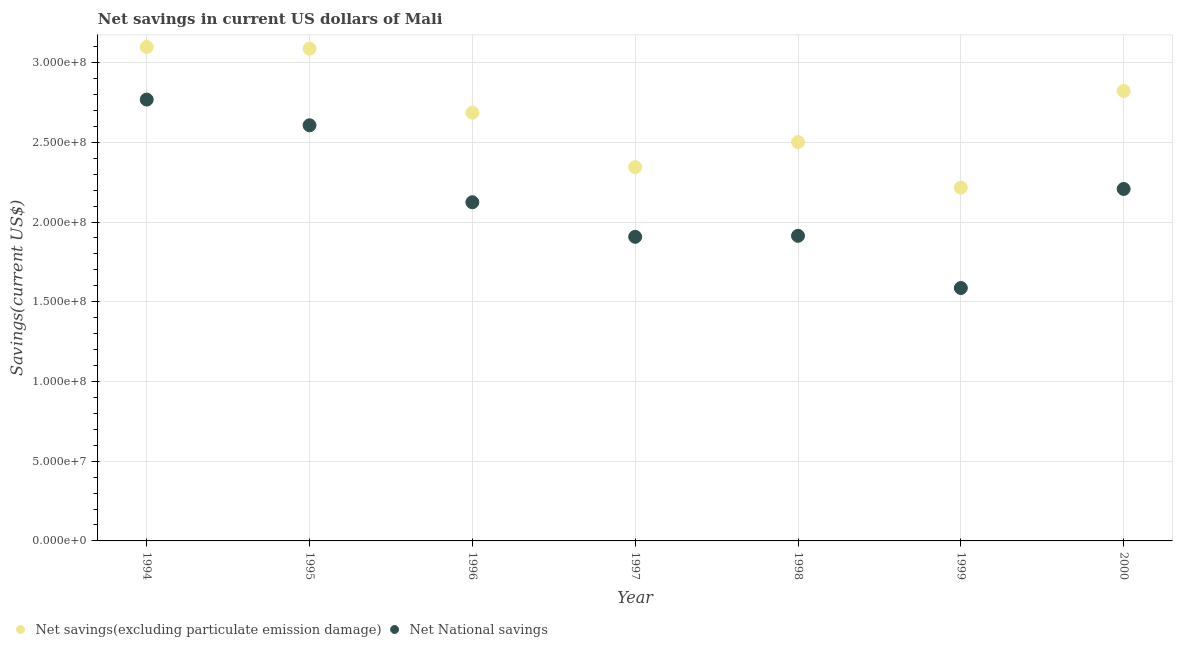What is the net savings(excluding particulate emission damage) in 1995?
Ensure brevity in your answer.  3.09e+08. Across all years, what is the maximum net national savings?
Your answer should be compact. 2.77e+08. Across all years, what is the minimum net national savings?
Your answer should be very brief. 1.59e+08. What is the total net savings(excluding particulate emission damage) in the graph?
Offer a very short reply. 1.88e+09. What is the difference between the net savings(excluding particulate emission damage) in 1999 and that in 2000?
Provide a short and direct response. -6.06e+07. What is the difference between the net national savings in 1999 and the net savings(excluding particulate emission damage) in 1996?
Give a very brief answer. -1.10e+08. What is the average net savings(excluding particulate emission damage) per year?
Your response must be concise. 2.68e+08. In the year 1998, what is the difference between the net savings(excluding particulate emission damage) and net national savings?
Provide a short and direct response. 5.88e+07. In how many years, is the net national savings greater than 140000000 US$?
Offer a terse response. 7. What is the ratio of the net savings(excluding particulate emission damage) in 1994 to that in 1998?
Your answer should be very brief. 1.24. What is the difference between the highest and the second highest net savings(excluding particulate emission damage)?
Provide a short and direct response. 1.12e+06. What is the difference between the highest and the lowest net national savings?
Make the answer very short. 1.18e+08. How many dotlines are there?
Ensure brevity in your answer.  2. How many years are there in the graph?
Your answer should be very brief. 7. Does the graph contain any zero values?
Provide a short and direct response. No. Where does the legend appear in the graph?
Make the answer very short. Bottom left. How are the legend labels stacked?
Offer a terse response. Horizontal. What is the title of the graph?
Your response must be concise. Net savings in current US dollars of Mali. Does "Register a business" appear as one of the legend labels in the graph?
Offer a very short reply. No. What is the label or title of the X-axis?
Your answer should be very brief. Year. What is the label or title of the Y-axis?
Make the answer very short. Savings(current US$). What is the Savings(current US$) in Net savings(excluding particulate emission damage) in 1994?
Offer a terse response. 3.10e+08. What is the Savings(current US$) of Net National savings in 1994?
Offer a terse response. 2.77e+08. What is the Savings(current US$) of Net savings(excluding particulate emission damage) in 1995?
Provide a succinct answer. 3.09e+08. What is the Savings(current US$) in Net National savings in 1995?
Your answer should be compact. 2.61e+08. What is the Savings(current US$) of Net savings(excluding particulate emission damage) in 1996?
Provide a succinct answer. 2.69e+08. What is the Savings(current US$) of Net National savings in 1996?
Your answer should be very brief. 2.12e+08. What is the Savings(current US$) in Net savings(excluding particulate emission damage) in 1997?
Your answer should be compact. 2.34e+08. What is the Savings(current US$) of Net National savings in 1997?
Offer a very short reply. 1.91e+08. What is the Savings(current US$) of Net savings(excluding particulate emission damage) in 1998?
Ensure brevity in your answer.  2.50e+08. What is the Savings(current US$) of Net National savings in 1998?
Your answer should be compact. 1.91e+08. What is the Savings(current US$) in Net savings(excluding particulate emission damage) in 1999?
Ensure brevity in your answer.  2.22e+08. What is the Savings(current US$) in Net National savings in 1999?
Your response must be concise. 1.59e+08. What is the Savings(current US$) in Net savings(excluding particulate emission damage) in 2000?
Offer a very short reply. 2.82e+08. What is the Savings(current US$) in Net National savings in 2000?
Offer a very short reply. 2.21e+08. Across all years, what is the maximum Savings(current US$) in Net savings(excluding particulate emission damage)?
Offer a terse response. 3.10e+08. Across all years, what is the maximum Savings(current US$) of Net National savings?
Offer a very short reply. 2.77e+08. Across all years, what is the minimum Savings(current US$) of Net savings(excluding particulate emission damage)?
Your response must be concise. 2.22e+08. Across all years, what is the minimum Savings(current US$) of Net National savings?
Your answer should be very brief. 1.59e+08. What is the total Savings(current US$) in Net savings(excluding particulate emission damage) in the graph?
Your answer should be compact. 1.88e+09. What is the total Savings(current US$) in Net National savings in the graph?
Your answer should be compact. 1.51e+09. What is the difference between the Savings(current US$) of Net savings(excluding particulate emission damage) in 1994 and that in 1995?
Make the answer very short. 1.12e+06. What is the difference between the Savings(current US$) in Net National savings in 1994 and that in 1995?
Ensure brevity in your answer.  1.61e+07. What is the difference between the Savings(current US$) of Net savings(excluding particulate emission damage) in 1994 and that in 1996?
Offer a terse response. 4.13e+07. What is the difference between the Savings(current US$) of Net National savings in 1994 and that in 1996?
Your answer should be very brief. 6.44e+07. What is the difference between the Savings(current US$) in Net savings(excluding particulate emission damage) in 1994 and that in 1997?
Give a very brief answer. 7.54e+07. What is the difference between the Savings(current US$) in Net National savings in 1994 and that in 1997?
Keep it short and to the point. 8.61e+07. What is the difference between the Savings(current US$) of Net savings(excluding particulate emission damage) in 1994 and that in 1998?
Make the answer very short. 5.97e+07. What is the difference between the Savings(current US$) in Net National savings in 1994 and that in 1998?
Your response must be concise. 8.54e+07. What is the difference between the Savings(current US$) in Net savings(excluding particulate emission damage) in 1994 and that in 1999?
Provide a short and direct response. 8.82e+07. What is the difference between the Savings(current US$) in Net National savings in 1994 and that in 1999?
Offer a terse response. 1.18e+08. What is the difference between the Savings(current US$) in Net savings(excluding particulate emission damage) in 1994 and that in 2000?
Keep it short and to the point. 2.76e+07. What is the difference between the Savings(current US$) of Net National savings in 1994 and that in 2000?
Provide a short and direct response. 5.61e+07. What is the difference between the Savings(current US$) of Net savings(excluding particulate emission damage) in 1995 and that in 1996?
Provide a succinct answer. 4.02e+07. What is the difference between the Savings(current US$) in Net National savings in 1995 and that in 1996?
Ensure brevity in your answer.  4.83e+07. What is the difference between the Savings(current US$) of Net savings(excluding particulate emission damage) in 1995 and that in 1997?
Your answer should be compact. 7.43e+07. What is the difference between the Savings(current US$) in Net National savings in 1995 and that in 1997?
Provide a succinct answer. 6.99e+07. What is the difference between the Savings(current US$) of Net savings(excluding particulate emission damage) in 1995 and that in 1998?
Make the answer very short. 5.85e+07. What is the difference between the Savings(current US$) in Net National savings in 1995 and that in 1998?
Offer a very short reply. 6.93e+07. What is the difference between the Savings(current US$) in Net savings(excluding particulate emission damage) in 1995 and that in 1999?
Your answer should be compact. 8.71e+07. What is the difference between the Savings(current US$) of Net National savings in 1995 and that in 1999?
Offer a very short reply. 1.02e+08. What is the difference between the Savings(current US$) in Net savings(excluding particulate emission damage) in 1995 and that in 2000?
Offer a terse response. 2.65e+07. What is the difference between the Savings(current US$) of Net National savings in 1995 and that in 2000?
Your answer should be compact. 3.99e+07. What is the difference between the Savings(current US$) of Net savings(excluding particulate emission damage) in 1996 and that in 1997?
Provide a short and direct response. 3.41e+07. What is the difference between the Savings(current US$) of Net National savings in 1996 and that in 1997?
Offer a terse response. 2.17e+07. What is the difference between the Savings(current US$) in Net savings(excluding particulate emission damage) in 1996 and that in 1998?
Keep it short and to the point. 1.84e+07. What is the difference between the Savings(current US$) of Net National savings in 1996 and that in 1998?
Your answer should be compact. 2.11e+07. What is the difference between the Savings(current US$) of Net savings(excluding particulate emission damage) in 1996 and that in 1999?
Provide a succinct answer. 4.70e+07. What is the difference between the Savings(current US$) in Net National savings in 1996 and that in 1999?
Ensure brevity in your answer.  5.38e+07. What is the difference between the Savings(current US$) in Net savings(excluding particulate emission damage) in 1996 and that in 2000?
Make the answer very short. -1.36e+07. What is the difference between the Savings(current US$) of Net National savings in 1996 and that in 2000?
Make the answer very short. -8.33e+06. What is the difference between the Savings(current US$) in Net savings(excluding particulate emission damage) in 1997 and that in 1998?
Offer a terse response. -1.57e+07. What is the difference between the Savings(current US$) of Net National savings in 1997 and that in 1998?
Your response must be concise. -6.31e+05. What is the difference between the Savings(current US$) of Net savings(excluding particulate emission damage) in 1997 and that in 1999?
Your response must be concise. 1.29e+07. What is the difference between the Savings(current US$) in Net National savings in 1997 and that in 1999?
Provide a short and direct response. 3.21e+07. What is the difference between the Savings(current US$) of Net savings(excluding particulate emission damage) in 1997 and that in 2000?
Make the answer very short. -4.77e+07. What is the difference between the Savings(current US$) in Net National savings in 1997 and that in 2000?
Keep it short and to the point. -3.00e+07. What is the difference between the Savings(current US$) of Net savings(excluding particulate emission damage) in 1998 and that in 1999?
Make the answer very short. 2.86e+07. What is the difference between the Savings(current US$) of Net National savings in 1998 and that in 1999?
Your answer should be very brief. 3.27e+07. What is the difference between the Savings(current US$) of Net savings(excluding particulate emission damage) in 1998 and that in 2000?
Make the answer very short. -3.20e+07. What is the difference between the Savings(current US$) of Net National savings in 1998 and that in 2000?
Offer a terse response. -2.94e+07. What is the difference between the Savings(current US$) in Net savings(excluding particulate emission damage) in 1999 and that in 2000?
Your answer should be very brief. -6.06e+07. What is the difference between the Savings(current US$) in Net National savings in 1999 and that in 2000?
Give a very brief answer. -6.21e+07. What is the difference between the Savings(current US$) of Net savings(excluding particulate emission damage) in 1994 and the Savings(current US$) of Net National savings in 1995?
Make the answer very short. 4.91e+07. What is the difference between the Savings(current US$) of Net savings(excluding particulate emission damage) in 1994 and the Savings(current US$) of Net National savings in 1996?
Make the answer very short. 9.74e+07. What is the difference between the Savings(current US$) of Net savings(excluding particulate emission damage) in 1994 and the Savings(current US$) of Net National savings in 1997?
Keep it short and to the point. 1.19e+08. What is the difference between the Savings(current US$) in Net savings(excluding particulate emission damage) in 1994 and the Savings(current US$) in Net National savings in 1998?
Ensure brevity in your answer.  1.18e+08. What is the difference between the Savings(current US$) in Net savings(excluding particulate emission damage) in 1994 and the Savings(current US$) in Net National savings in 1999?
Keep it short and to the point. 1.51e+08. What is the difference between the Savings(current US$) in Net savings(excluding particulate emission damage) in 1994 and the Savings(current US$) in Net National savings in 2000?
Give a very brief answer. 8.91e+07. What is the difference between the Savings(current US$) in Net savings(excluding particulate emission damage) in 1995 and the Savings(current US$) in Net National savings in 1996?
Ensure brevity in your answer.  9.63e+07. What is the difference between the Savings(current US$) in Net savings(excluding particulate emission damage) in 1995 and the Savings(current US$) in Net National savings in 1997?
Give a very brief answer. 1.18e+08. What is the difference between the Savings(current US$) of Net savings(excluding particulate emission damage) in 1995 and the Savings(current US$) of Net National savings in 1998?
Ensure brevity in your answer.  1.17e+08. What is the difference between the Savings(current US$) in Net savings(excluding particulate emission damage) in 1995 and the Savings(current US$) in Net National savings in 1999?
Make the answer very short. 1.50e+08. What is the difference between the Savings(current US$) of Net savings(excluding particulate emission damage) in 1995 and the Savings(current US$) of Net National savings in 2000?
Offer a very short reply. 8.80e+07. What is the difference between the Savings(current US$) in Net savings(excluding particulate emission damage) in 1996 and the Savings(current US$) in Net National savings in 1997?
Make the answer very short. 7.78e+07. What is the difference between the Savings(current US$) in Net savings(excluding particulate emission damage) in 1996 and the Savings(current US$) in Net National savings in 1998?
Offer a terse response. 7.72e+07. What is the difference between the Savings(current US$) of Net savings(excluding particulate emission damage) in 1996 and the Savings(current US$) of Net National savings in 1999?
Your response must be concise. 1.10e+08. What is the difference between the Savings(current US$) in Net savings(excluding particulate emission damage) in 1996 and the Savings(current US$) in Net National savings in 2000?
Provide a short and direct response. 4.78e+07. What is the difference between the Savings(current US$) in Net savings(excluding particulate emission damage) in 1997 and the Savings(current US$) in Net National savings in 1998?
Your answer should be very brief. 4.31e+07. What is the difference between the Savings(current US$) of Net savings(excluding particulate emission damage) in 1997 and the Savings(current US$) of Net National savings in 1999?
Ensure brevity in your answer.  7.58e+07. What is the difference between the Savings(current US$) in Net savings(excluding particulate emission damage) in 1997 and the Savings(current US$) in Net National savings in 2000?
Provide a short and direct response. 1.37e+07. What is the difference between the Savings(current US$) of Net savings(excluding particulate emission damage) in 1998 and the Savings(current US$) of Net National savings in 1999?
Your answer should be very brief. 9.15e+07. What is the difference between the Savings(current US$) in Net savings(excluding particulate emission damage) in 1998 and the Savings(current US$) in Net National savings in 2000?
Keep it short and to the point. 2.94e+07. What is the difference between the Savings(current US$) in Net savings(excluding particulate emission damage) in 1999 and the Savings(current US$) in Net National savings in 2000?
Ensure brevity in your answer.  8.42e+05. What is the average Savings(current US$) of Net savings(excluding particulate emission damage) per year?
Make the answer very short. 2.68e+08. What is the average Savings(current US$) in Net National savings per year?
Your answer should be compact. 2.16e+08. In the year 1994, what is the difference between the Savings(current US$) of Net savings(excluding particulate emission damage) and Savings(current US$) of Net National savings?
Keep it short and to the point. 3.30e+07. In the year 1995, what is the difference between the Savings(current US$) in Net savings(excluding particulate emission damage) and Savings(current US$) in Net National savings?
Make the answer very short. 4.80e+07. In the year 1996, what is the difference between the Savings(current US$) in Net savings(excluding particulate emission damage) and Savings(current US$) in Net National savings?
Make the answer very short. 5.61e+07. In the year 1997, what is the difference between the Savings(current US$) in Net savings(excluding particulate emission damage) and Savings(current US$) in Net National savings?
Provide a short and direct response. 4.37e+07. In the year 1998, what is the difference between the Savings(current US$) of Net savings(excluding particulate emission damage) and Savings(current US$) of Net National savings?
Offer a terse response. 5.88e+07. In the year 1999, what is the difference between the Savings(current US$) of Net savings(excluding particulate emission damage) and Savings(current US$) of Net National savings?
Your answer should be compact. 6.30e+07. In the year 2000, what is the difference between the Savings(current US$) of Net savings(excluding particulate emission damage) and Savings(current US$) of Net National savings?
Offer a very short reply. 6.14e+07. What is the ratio of the Savings(current US$) in Net National savings in 1994 to that in 1995?
Your response must be concise. 1.06. What is the ratio of the Savings(current US$) of Net savings(excluding particulate emission damage) in 1994 to that in 1996?
Ensure brevity in your answer.  1.15. What is the ratio of the Savings(current US$) of Net National savings in 1994 to that in 1996?
Make the answer very short. 1.3. What is the ratio of the Savings(current US$) in Net savings(excluding particulate emission damage) in 1994 to that in 1997?
Offer a terse response. 1.32. What is the ratio of the Savings(current US$) in Net National savings in 1994 to that in 1997?
Provide a succinct answer. 1.45. What is the ratio of the Savings(current US$) of Net savings(excluding particulate emission damage) in 1994 to that in 1998?
Offer a very short reply. 1.24. What is the ratio of the Savings(current US$) of Net National savings in 1994 to that in 1998?
Provide a short and direct response. 1.45. What is the ratio of the Savings(current US$) in Net savings(excluding particulate emission damage) in 1994 to that in 1999?
Provide a succinct answer. 1.4. What is the ratio of the Savings(current US$) in Net National savings in 1994 to that in 1999?
Make the answer very short. 1.75. What is the ratio of the Savings(current US$) of Net savings(excluding particulate emission damage) in 1994 to that in 2000?
Your answer should be compact. 1.1. What is the ratio of the Savings(current US$) of Net National savings in 1994 to that in 2000?
Give a very brief answer. 1.25. What is the ratio of the Savings(current US$) of Net savings(excluding particulate emission damage) in 1995 to that in 1996?
Make the answer very short. 1.15. What is the ratio of the Savings(current US$) in Net National savings in 1995 to that in 1996?
Your response must be concise. 1.23. What is the ratio of the Savings(current US$) in Net savings(excluding particulate emission damage) in 1995 to that in 1997?
Provide a short and direct response. 1.32. What is the ratio of the Savings(current US$) in Net National savings in 1995 to that in 1997?
Give a very brief answer. 1.37. What is the ratio of the Savings(current US$) of Net savings(excluding particulate emission damage) in 1995 to that in 1998?
Ensure brevity in your answer.  1.23. What is the ratio of the Savings(current US$) in Net National savings in 1995 to that in 1998?
Keep it short and to the point. 1.36. What is the ratio of the Savings(current US$) in Net savings(excluding particulate emission damage) in 1995 to that in 1999?
Ensure brevity in your answer.  1.39. What is the ratio of the Savings(current US$) in Net National savings in 1995 to that in 1999?
Provide a short and direct response. 1.64. What is the ratio of the Savings(current US$) of Net savings(excluding particulate emission damage) in 1995 to that in 2000?
Keep it short and to the point. 1.09. What is the ratio of the Savings(current US$) of Net National savings in 1995 to that in 2000?
Your response must be concise. 1.18. What is the ratio of the Savings(current US$) of Net savings(excluding particulate emission damage) in 1996 to that in 1997?
Provide a short and direct response. 1.15. What is the ratio of the Savings(current US$) in Net National savings in 1996 to that in 1997?
Offer a terse response. 1.11. What is the ratio of the Savings(current US$) of Net savings(excluding particulate emission damage) in 1996 to that in 1998?
Provide a succinct answer. 1.07. What is the ratio of the Savings(current US$) in Net National savings in 1996 to that in 1998?
Your response must be concise. 1.11. What is the ratio of the Savings(current US$) of Net savings(excluding particulate emission damage) in 1996 to that in 1999?
Give a very brief answer. 1.21. What is the ratio of the Savings(current US$) in Net National savings in 1996 to that in 1999?
Provide a succinct answer. 1.34. What is the ratio of the Savings(current US$) of Net savings(excluding particulate emission damage) in 1996 to that in 2000?
Offer a very short reply. 0.95. What is the ratio of the Savings(current US$) of Net National savings in 1996 to that in 2000?
Keep it short and to the point. 0.96. What is the ratio of the Savings(current US$) in Net savings(excluding particulate emission damage) in 1997 to that in 1998?
Your answer should be compact. 0.94. What is the ratio of the Savings(current US$) in Net National savings in 1997 to that in 1998?
Offer a very short reply. 1. What is the ratio of the Savings(current US$) of Net savings(excluding particulate emission damage) in 1997 to that in 1999?
Make the answer very short. 1.06. What is the ratio of the Savings(current US$) of Net National savings in 1997 to that in 1999?
Give a very brief answer. 1.2. What is the ratio of the Savings(current US$) in Net savings(excluding particulate emission damage) in 1997 to that in 2000?
Provide a succinct answer. 0.83. What is the ratio of the Savings(current US$) of Net National savings in 1997 to that in 2000?
Offer a terse response. 0.86. What is the ratio of the Savings(current US$) in Net savings(excluding particulate emission damage) in 1998 to that in 1999?
Your response must be concise. 1.13. What is the ratio of the Savings(current US$) of Net National savings in 1998 to that in 1999?
Your answer should be very brief. 1.21. What is the ratio of the Savings(current US$) of Net savings(excluding particulate emission damage) in 1998 to that in 2000?
Offer a very short reply. 0.89. What is the ratio of the Savings(current US$) of Net National savings in 1998 to that in 2000?
Your response must be concise. 0.87. What is the ratio of the Savings(current US$) in Net savings(excluding particulate emission damage) in 1999 to that in 2000?
Offer a very short reply. 0.79. What is the ratio of the Savings(current US$) in Net National savings in 1999 to that in 2000?
Provide a succinct answer. 0.72. What is the difference between the highest and the second highest Savings(current US$) in Net savings(excluding particulate emission damage)?
Make the answer very short. 1.12e+06. What is the difference between the highest and the second highest Savings(current US$) of Net National savings?
Provide a short and direct response. 1.61e+07. What is the difference between the highest and the lowest Savings(current US$) in Net savings(excluding particulate emission damage)?
Your answer should be very brief. 8.82e+07. What is the difference between the highest and the lowest Savings(current US$) of Net National savings?
Give a very brief answer. 1.18e+08. 